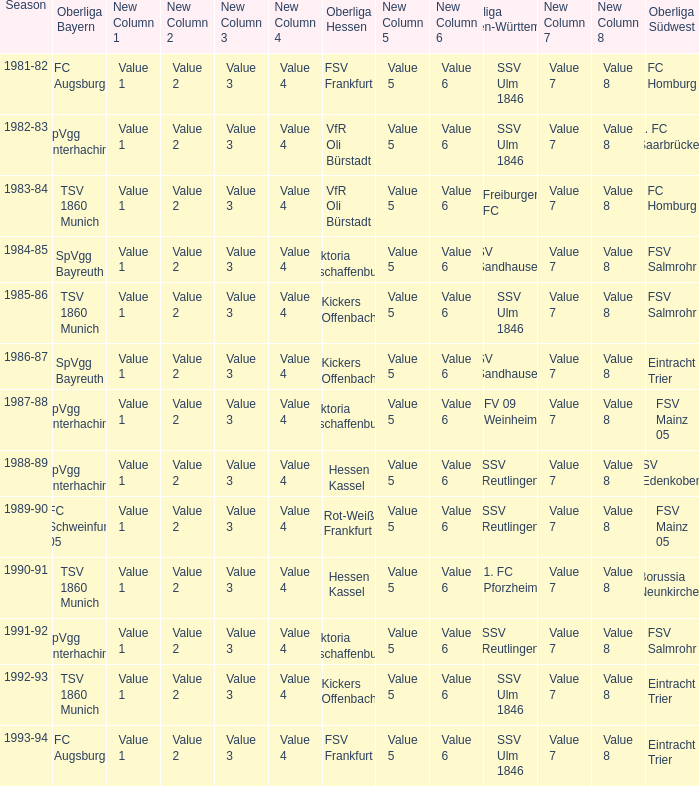Which Season ha spvgg bayreuth and eintracht trier? 1986-87. 